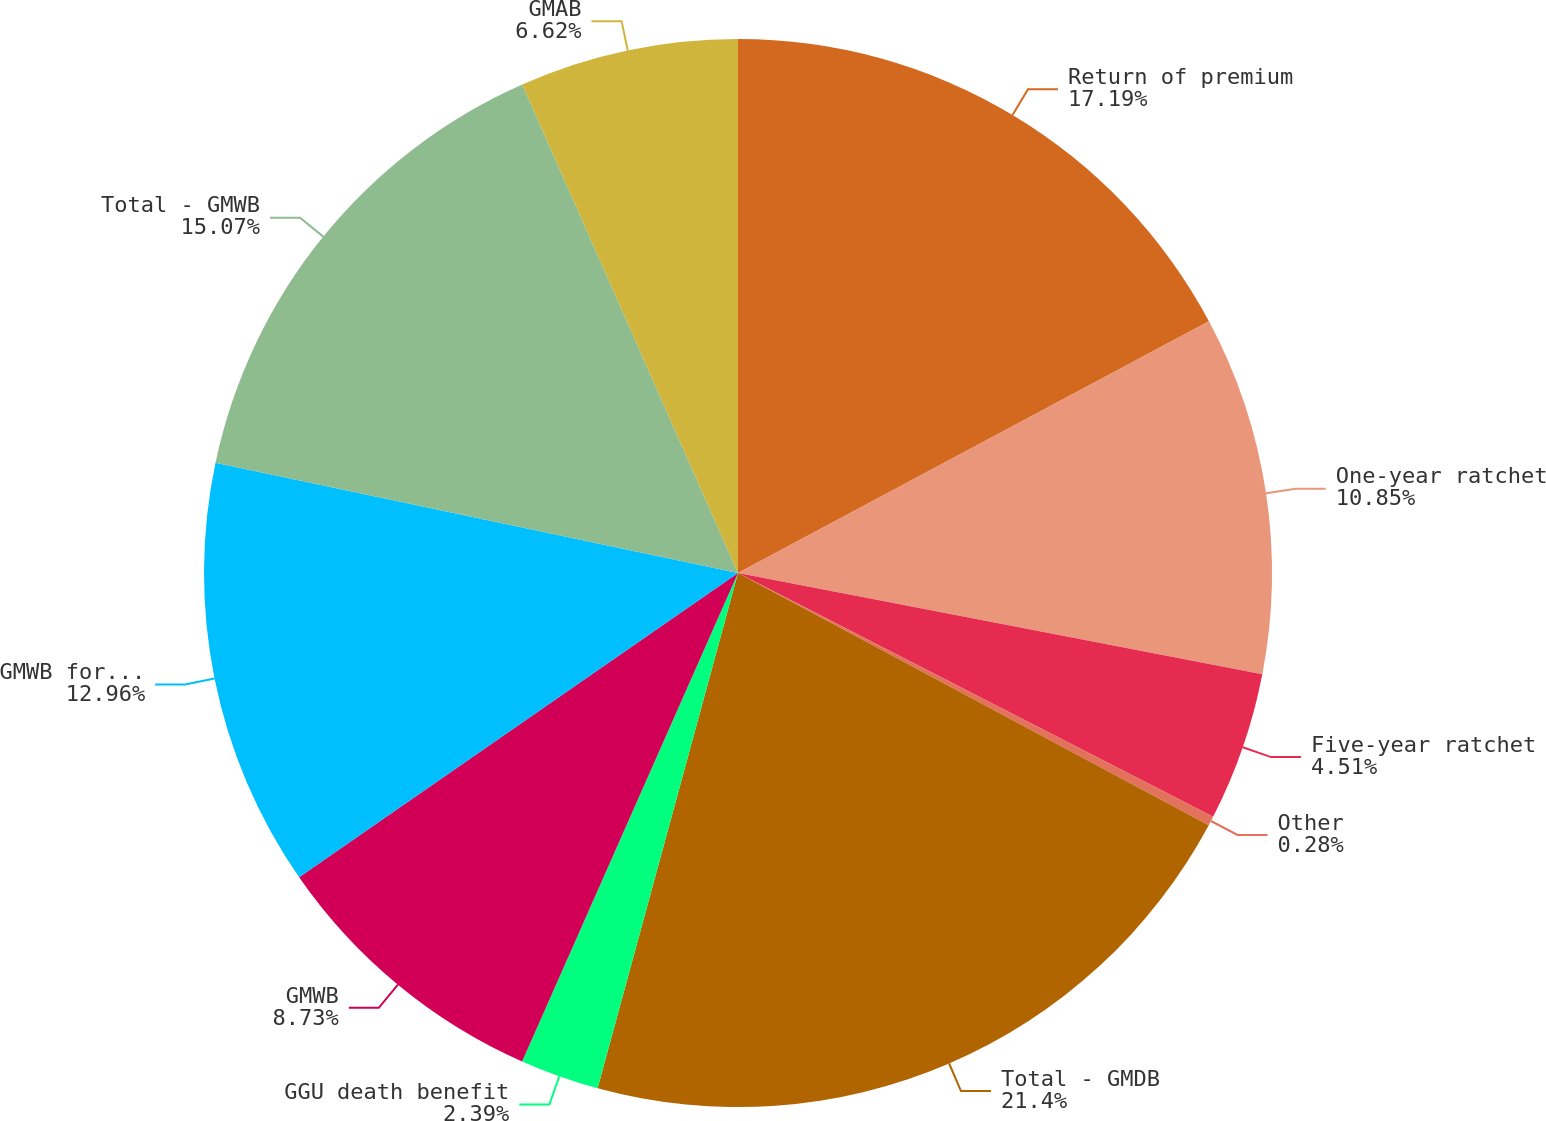Convert chart to OTSL. <chart><loc_0><loc_0><loc_500><loc_500><pie_chart><fcel>Return of premium<fcel>One-year ratchet<fcel>Five-year ratchet<fcel>Other<fcel>Total - GMDB<fcel>GGU death benefit<fcel>GMWB<fcel>GMWB for life<fcel>Total - GMWB<fcel>GMAB<nl><fcel>17.19%<fcel>10.85%<fcel>4.51%<fcel>0.28%<fcel>21.41%<fcel>2.39%<fcel>8.73%<fcel>12.96%<fcel>15.07%<fcel>6.62%<nl></chart> 